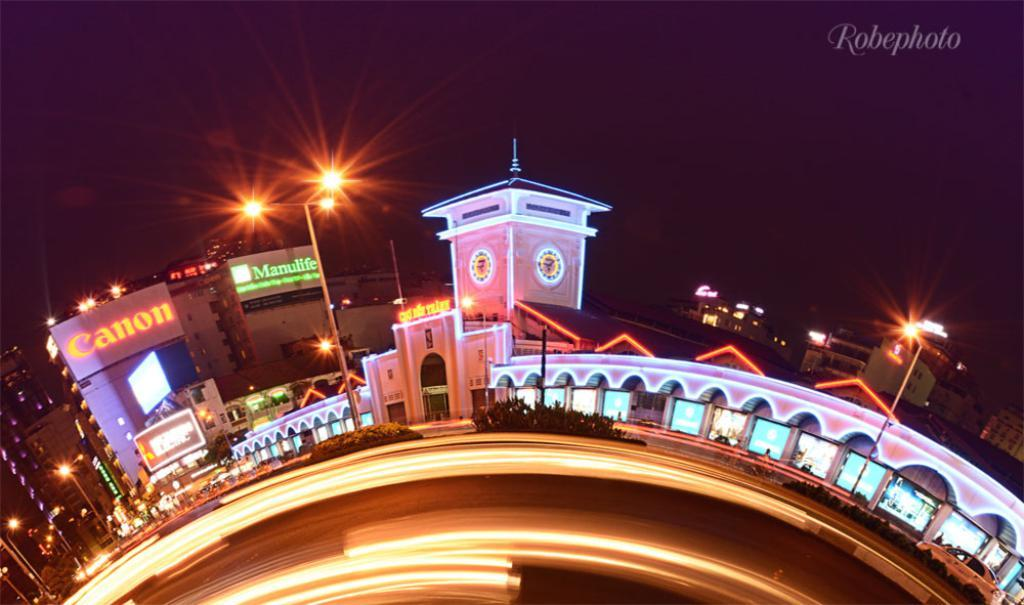<image>
Relay a brief, clear account of the picture shown. a stylized night scene of neon streets and signs by Robephoto 